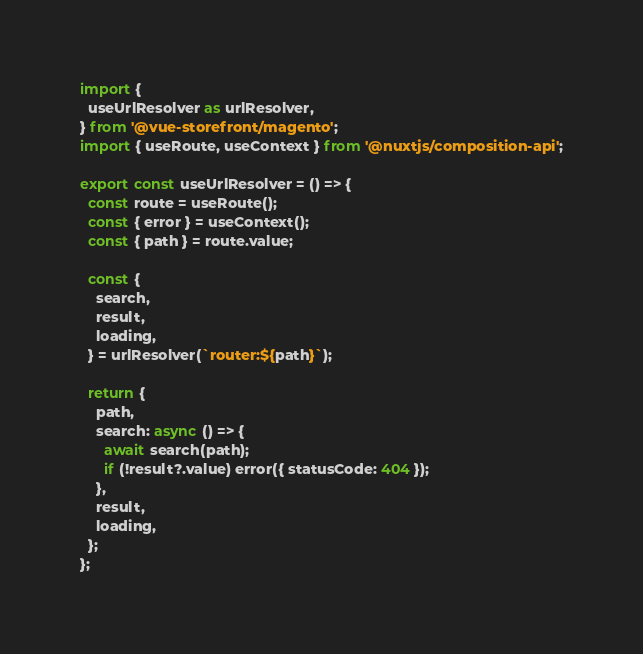<code> <loc_0><loc_0><loc_500><loc_500><_TypeScript_>import {
  useUrlResolver as urlResolver,
} from '@vue-storefront/magento';
import { useRoute, useContext } from '@nuxtjs/composition-api';

export const useUrlResolver = () => {
  const route = useRoute();
  const { error } = useContext();
  const { path } = route.value;

  const {
    search,
    result,
    loading,
  } = urlResolver(`router:${path}`);

  return {
    path,
    search: async () => {
      await search(path);
      if (!result?.value) error({ statusCode: 404 });
    },
    result,
    loading,
  };
};
</code> 